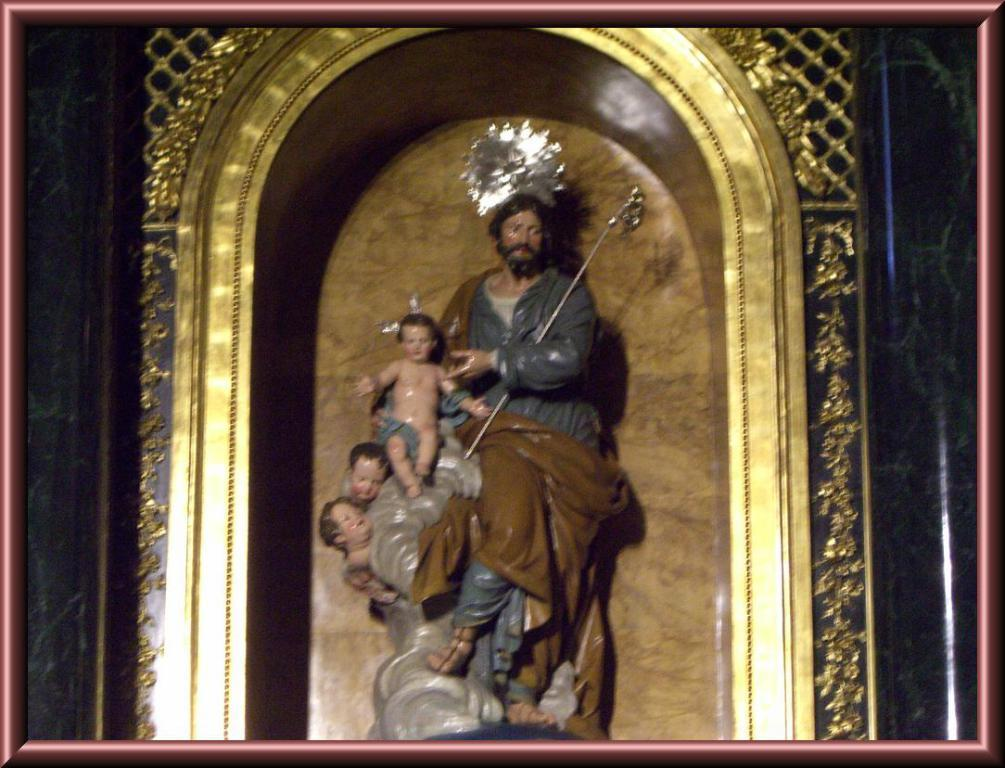What type of objects are depicted in the image? There are statues of people in the image. What colors are the statues? The statues are in brown, grey, and ash colors. What is one of the statues holding? One person depicted in the statues is holding a weapon. What is the background color in the image? There is a gold color background in the image. How many spoons can be seen in the image? There are no spoons present in the image. What type of machine is depicted in the image? There is no machine depicted in the image; it features statues of people. 